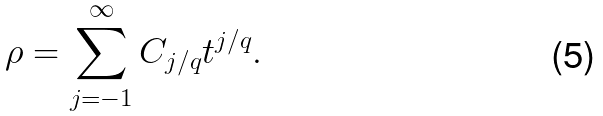<formula> <loc_0><loc_0><loc_500><loc_500>\rho = \sum _ { j = - 1 } ^ { \infty } C _ { j / q } t ^ { j / q } .</formula> 